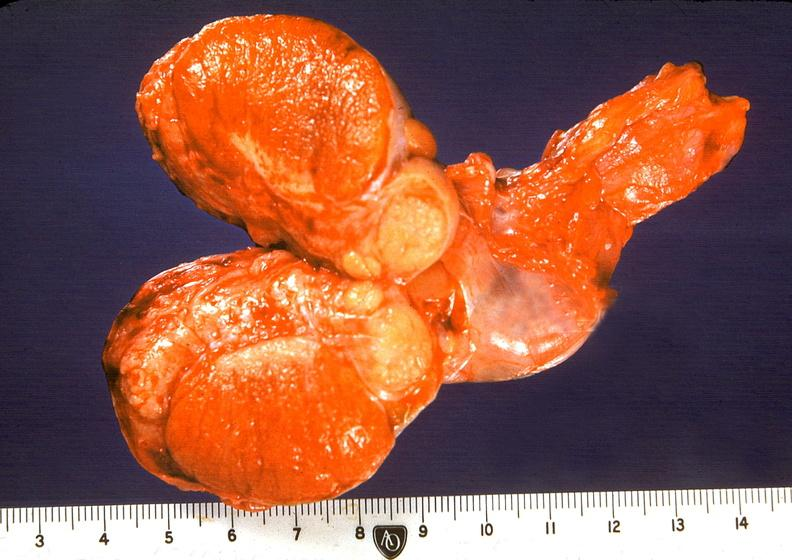what does this image show?
Answer the question using a single word or phrase. Orchitis and epididymitis 